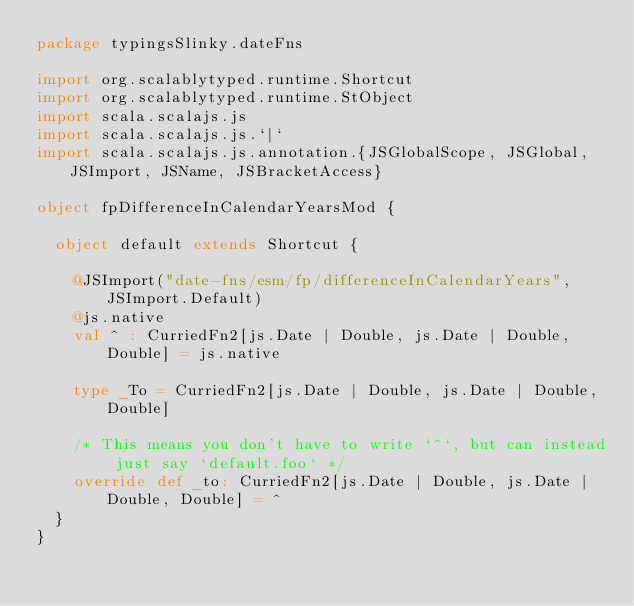Convert code to text. <code><loc_0><loc_0><loc_500><loc_500><_Scala_>package typingsSlinky.dateFns

import org.scalablytyped.runtime.Shortcut
import org.scalablytyped.runtime.StObject
import scala.scalajs.js
import scala.scalajs.js.`|`
import scala.scalajs.js.annotation.{JSGlobalScope, JSGlobal, JSImport, JSName, JSBracketAccess}

object fpDifferenceInCalendarYearsMod {
  
  object default extends Shortcut {
    
    @JSImport("date-fns/esm/fp/differenceInCalendarYears", JSImport.Default)
    @js.native
    val ^ : CurriedFn2[js.Date | Double, js.Date | Double, Double] = js.native
    
    type _To = CurriedFn2[js.Date | Double, js.Date | Double, Double]
    
    /* This means you don't have to write `^`, but can instead just say `default.foo` */
    override def _to: CurriedFn2[js.Date | Double, js.Date | Double, Double] = ^
  }
}
</code> 